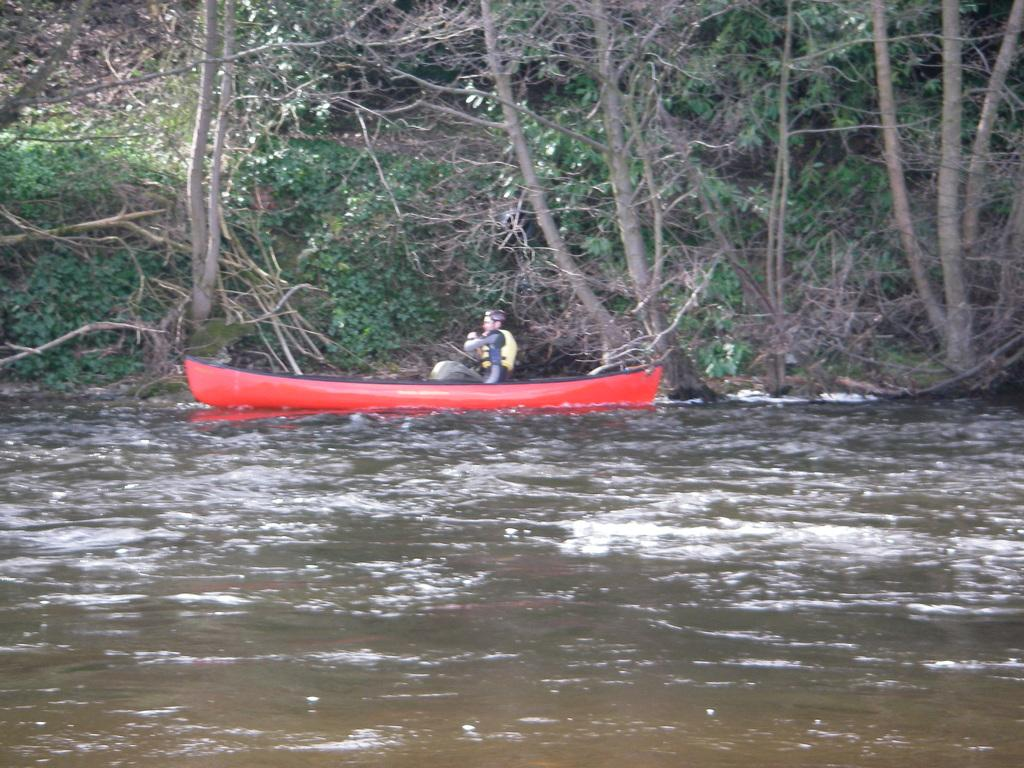What is the main subject of the image? There is a person in the image. What is the person doing in the image? The person is boating on the surface of the water. What can be seen in the background of the image? There are trees visible in the background of the image. Can you tell me how many elbows the person has in the image? The person in the image has two elbows, just like any other person. However, the image does not show the person's elbows, so it cannot be determined from the image alone. Is there a stranger in the image? The image does not show any strangers; it only shows the person who is boating. 